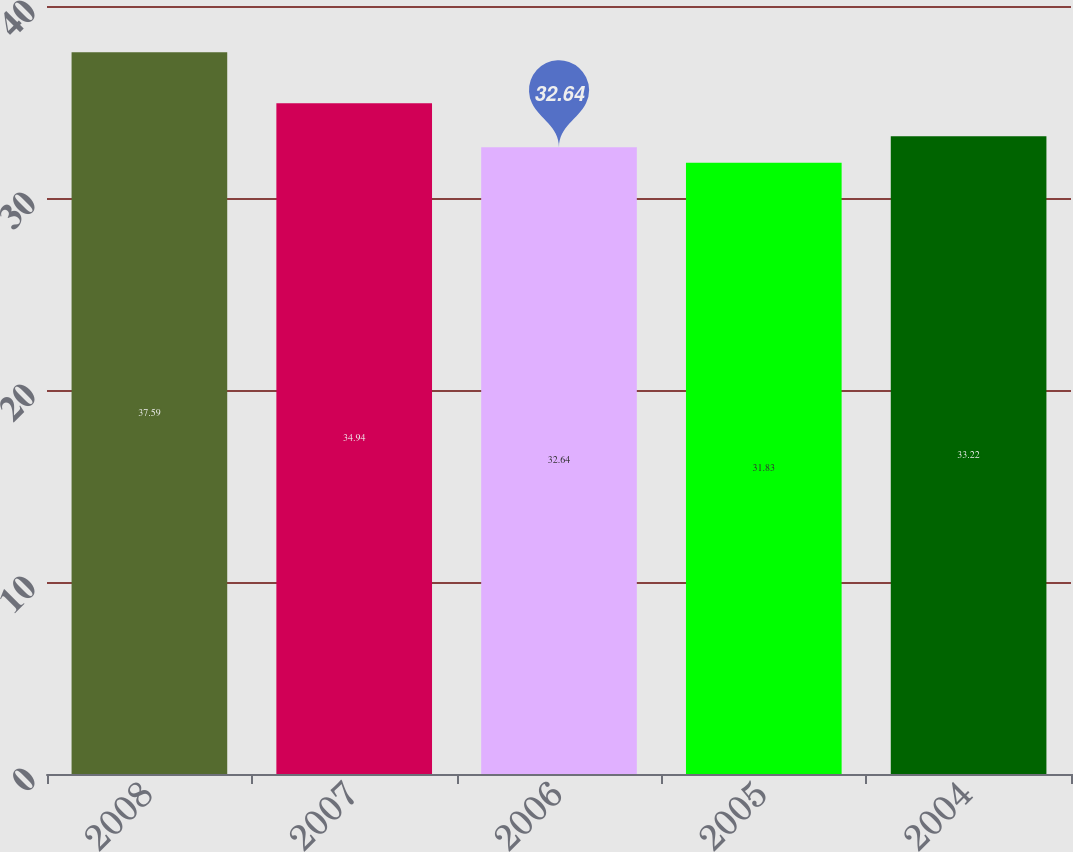Convert chart to OTSL. <chart><loc_0><loc_0><loc_500><loc_500><bar_chart><fcel>2008<fcel>2007<fcel>2006<fcel>2005<fcel>2004<nl><fcel>37.59<fcel>34.94<fcel>32.64<fcel>31.83<fcel>33.22<nl></chart> 